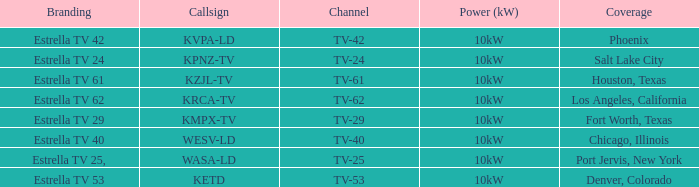Which area did estrella tv 62 provide coverage for? Los Angeles, California. 